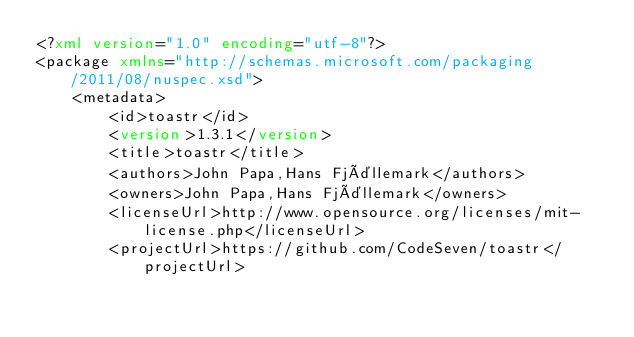Convert code to text. <code><loc_0><loc_0><loc_500><loc_500><_XML_><?xml version="1.0" encoding="utf-8"?>
<package xmlns="http://schemas.microsoft.com/packaging/2011/08/nuspec.xsd">
    <metadata>
        <id>toastr</id>
        <version>1.3.1</version>
        <title>toastr</title>
        <authors>John Papa,Hans Fjällemark</authors>
        <owners>John Papa,Hans Fjällemark</owners>
        <licenseUrl>http://www.opensource.org/licenses/mit-license.php</licenseUrl>
        <projectUrl>https://github.com/CodeSeven/toastr</projectUrl></code> 